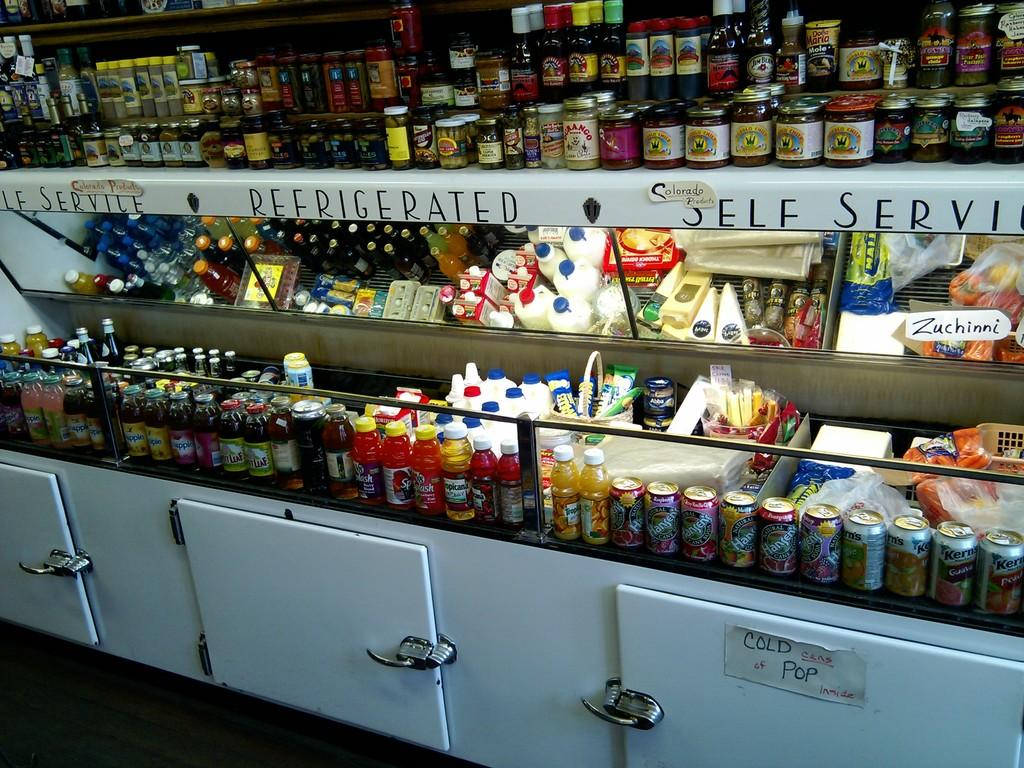<image>
Share a concise interpretation of the image provided. A section of a store says Refrigerated self service. 